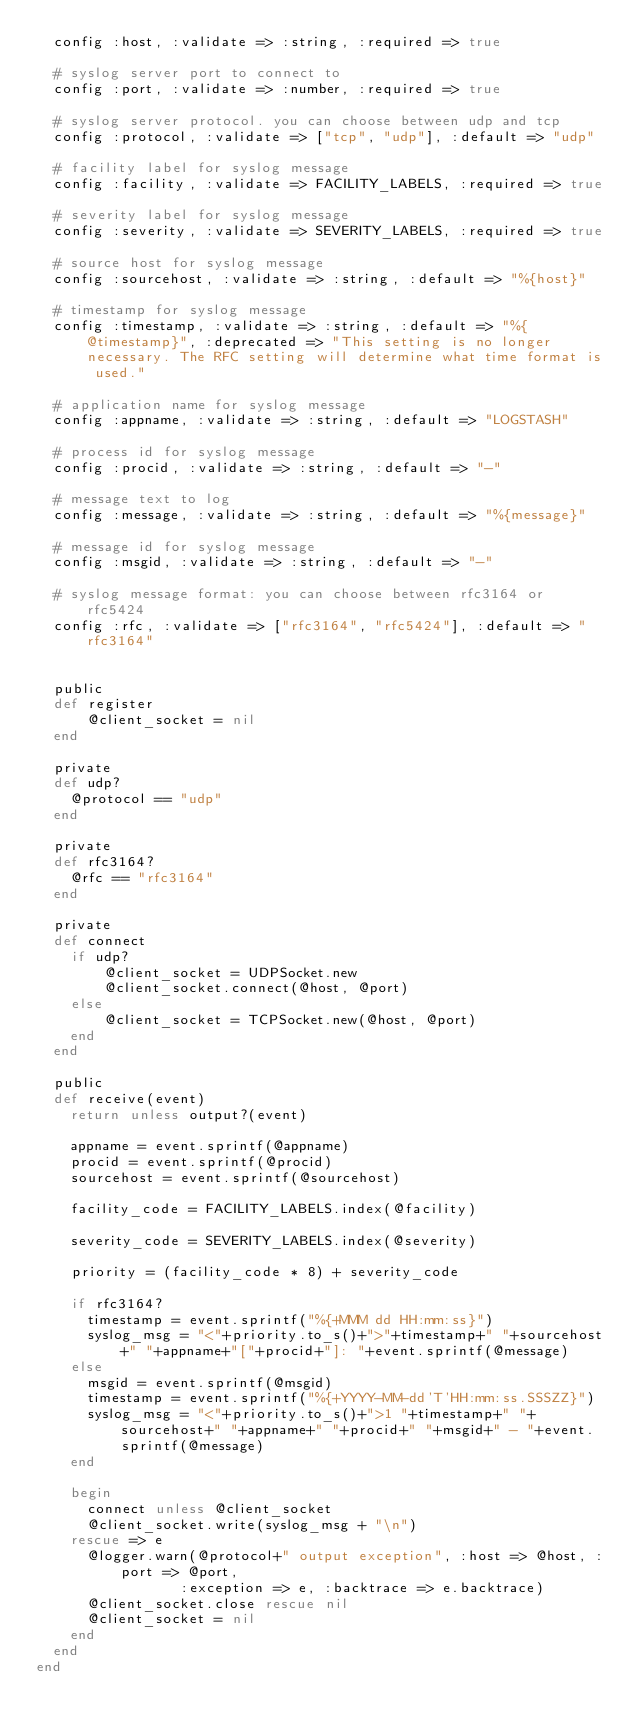Convert code to text. <code><loc_0><loc_0><loc_500><loc_500><_Ruby_>  config :host, :validate => :string, :required => true
  
  # syslog server port to connect to
  config :port, :validate => :number, :required => true

  # syslog server protocol. you can choose between udp and tcp
  config :protocol, :validate => ["tcp", "udp"], :default => "udp"

  # facility label for syslog message
  config :facility, :validate => FACILITY_LABELS, :required => true

  # severity label for syslog message
  config :severity, :validate => SEVERITY_LABELS, :required => true

  # source host for syslog message
  config :sourcehost, :validate => :string, :default => "%{host}"

  # timestamp for syslog message
  config :timestamp, :validate => :string, :default => "%{@timestamp}", :deprecated => "This setting is no longer necessary. The RFC setting will determine what time format is used."

  # application name for syslog message
  config :appname, :validate => :string, :default => "LOGSTASH"

  # process id for syslog message
  config :procid, :validate => :string, :default => "-"

  # message text to log
  config :message, :validate => :string, :default => "%{message}"
 
  # message id for syslog message
  config :msgid, :validate => :string, :default => "-"

  # syslog message format: you can choose between rfc3164 or rfc5424
  config :rfc, :validate => ["rfc3164", "rfc5424"], :default => "rfc3164"

  
  public
  def register
      @client_socket = nil
  end

  private
  def udp?
    @protocol == "udp"
  end

  private
  def rfc3164?
    @rfc == "rfc3164"
  end 

  private
  def connect
    if udp?
        @client_socket = UDPSocket.new
        @client_socket.connect(@host, @port)
    else
        @client_socket = TCPSocket.new(@host, @port)
    end
  end

  public
  def receive(event)
    return unless output?(event)

    appname = event.sprintf(@appname)
    procid = event.sprintf(@procid)
    sourcehost = event.sprintf(@sourcehost)

    facility_code = FACILITY_LABELS.index(@facility)

    severity_code = SEVERITY_LABELS.index(@severity)

    priority = (facility_code * 8) + severity_code

    if rfc3164?
      timestamp = event.sprintf("%{+MMM dd HH:mm:ss}")
      syslog_msg = "<"+priority.to_s()+">"+timestamp+" "+sourcehost+" "+appname+"["+procid+"]: "+event.sprintf(@message)
    else
      msgid = event.sprintf(@msgid)
      timestamp = event.sprintf("%{+YYYY-MM-dd'T'HH:mm:ss.SSSZZ}")
      syslog_msg = "<"+priority.to_s()+">1 "+timestamp+" "+sourcehost+" "+appname+" "+procid+" "+msgid+" - "+event.sprintf(@message)
    end

    begin
      connect unless @client_socket
      @client_socket.write(syslog_msg + "\n")
    rescue => e
      @logger.warn(@protocol+" output exception", :host => @host, :port => @port,
                 :exception => e, :backtrace => e.backtrace)
      @client_socket.close rescue nil
      @client_socket = nil
    end
  end
end
</code> 